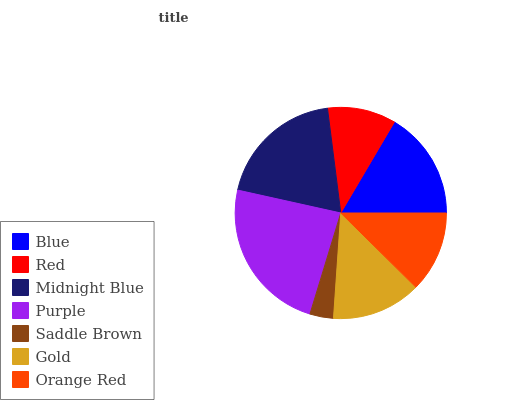Is Saddle Brown the minimum?
Answer yes or no. Yes. Is Purple the maximum?
Answer yes or no. Yes. Is Red the minimum?
Answer yes or no. No. Is Red the maximum?
Answer yes or no. No. Is Blue greater than Red?
Answer yes or no. Yes. Is Red less than Blue?
Answer yes or no. Yes. Is Red greater than Blue?
Answer yes or no. No. Is Blue less than Red?
Answer yes or no. No. Is Gold the high median?
Answer yes or no. Yes. Is Gold the low median?
Answer yes or no. Yes. Is Purple the high median?
Answer yes or no. No. Is Red the low median?
Answer yes or no. No. 